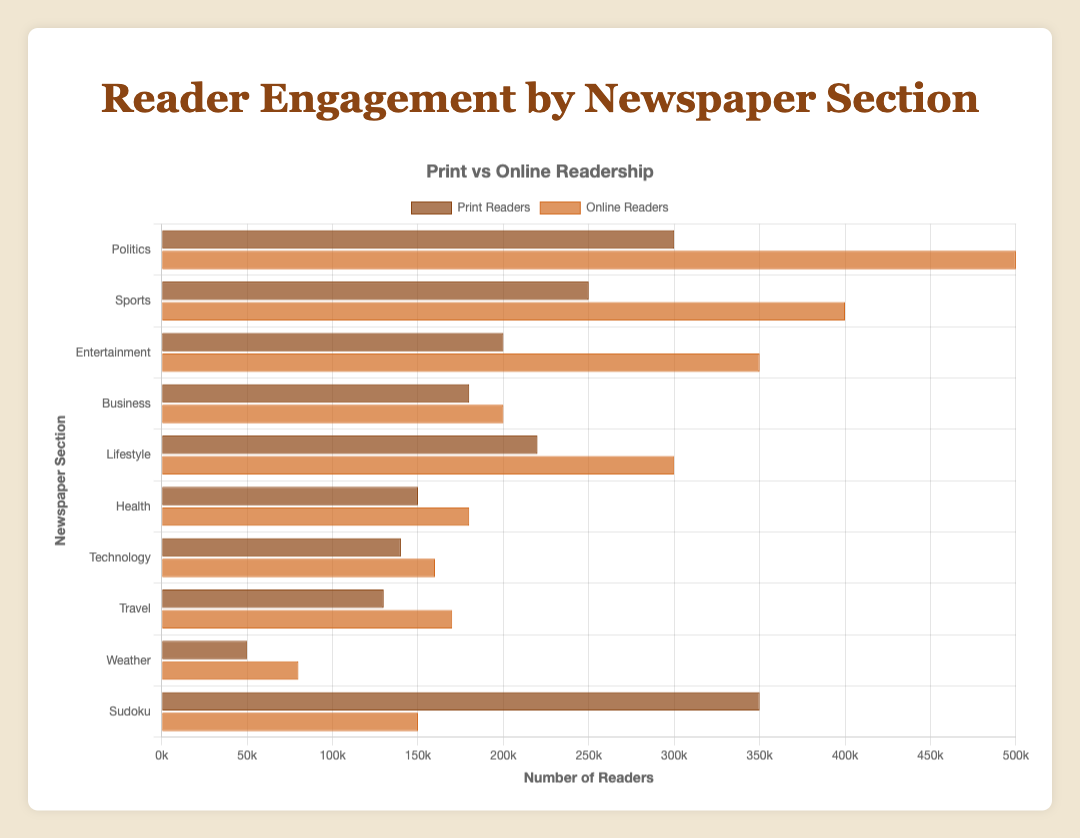What section has the highest number of print readers? Looking at the horizontal bars representing print readers, the longest bar corresponds to the Sudoku section, indicating it has the highest number of print readers.
Answer: Sudoku Which section receives the most comments online? By comparing the segments representing the number of comments for each section, the Sports section shows the longest segment, indicating it has the most online comments.
Answer: Sports What's the total number of readers (print and online) for the Lifestyle section? Sum the print readers and online readers for the Lifestyle section (220,000 + 300,000).
Answer: 520,000 How many more online readers does the Politics section have compared to the Technology section? Subtract the number of online readers in the Technology section from the number in the Politics section (500,000 - 160,000).
Answer: 340,000 Which section has more shares, Entertainment or Health? Compare the lengths of the segments representing the number of shares for both sections. The Entertainment section has a longer segment than the Health section.
Answer: Entertainment What is the average number of Likes across all sections? Sum the number of Likes for all sections and divide by the number of sections ((20000 + 35000 + 25000 + 15000 + 28000 + 12000 + 18000 + 22000 + 5000 + 40000) / 10) = 24000
Answer: 24000 What section has the second highest online readership? Politics has the highest online readership. By comparing the next longest bar, the Sports section has the second highest online readership.
Answer: Sports Is the number of shares for the Sudoku section more than the combined shares of the Health and Weather sections? Compare the number of shares in Sudoku (10000) to the sum of shares in Health and Weather (2500 + 700 = 3200).
Answer: Yes Which section has the least overall engagement (sum of print readers, online readers, likes, comments and shares)? Calculate the sum for each section and identify the smallest total. The Weather section has the smallest sum ((50000+80000+5000+800+700) = 136500).
Answer: Weather What is the difference in the total number of readers (print + online) between the Sudoku and Politics sections? Subtract the total readers for Politics (300,000 + 500,000) from the total readers for Sudoku (350,000 + 150,000). (800,000 - 500,000) = 0
Answer: 0 